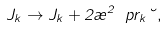Convert formula to latex. <formula><loc_0><loc_0><loc_500><loc_500>J _ { k } \to J _ { k } + 2 \rho ^ { 2 } \ p r _ { k } \lambda ,</formula> 